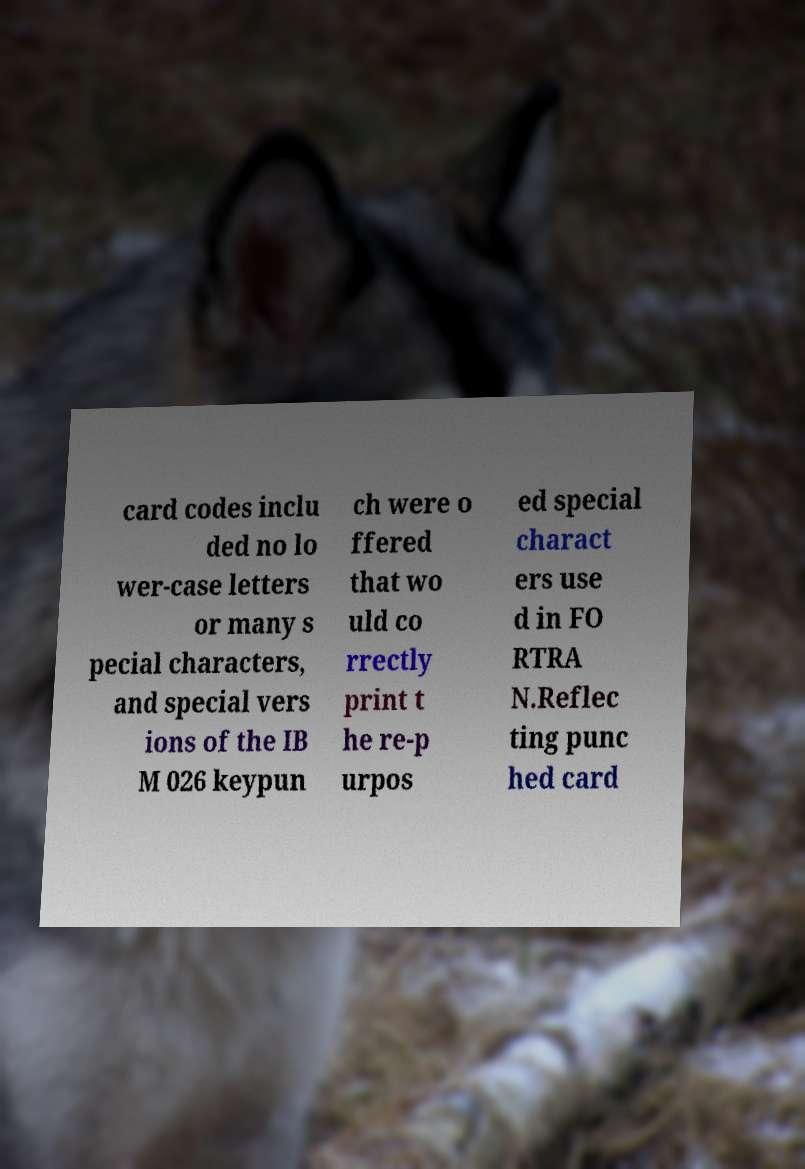Could you assist in decoding the text presented in this image and type it out clearly? card codes inclu ded no lo wer-case letters or many s pecial characters, and special vers ions of the IB M 026 keypun ch were o ffered that wo uld co rrectly print t he re-p urpos ed special charact ers use d in FO RTRA N.Reflec ting punc hed card 